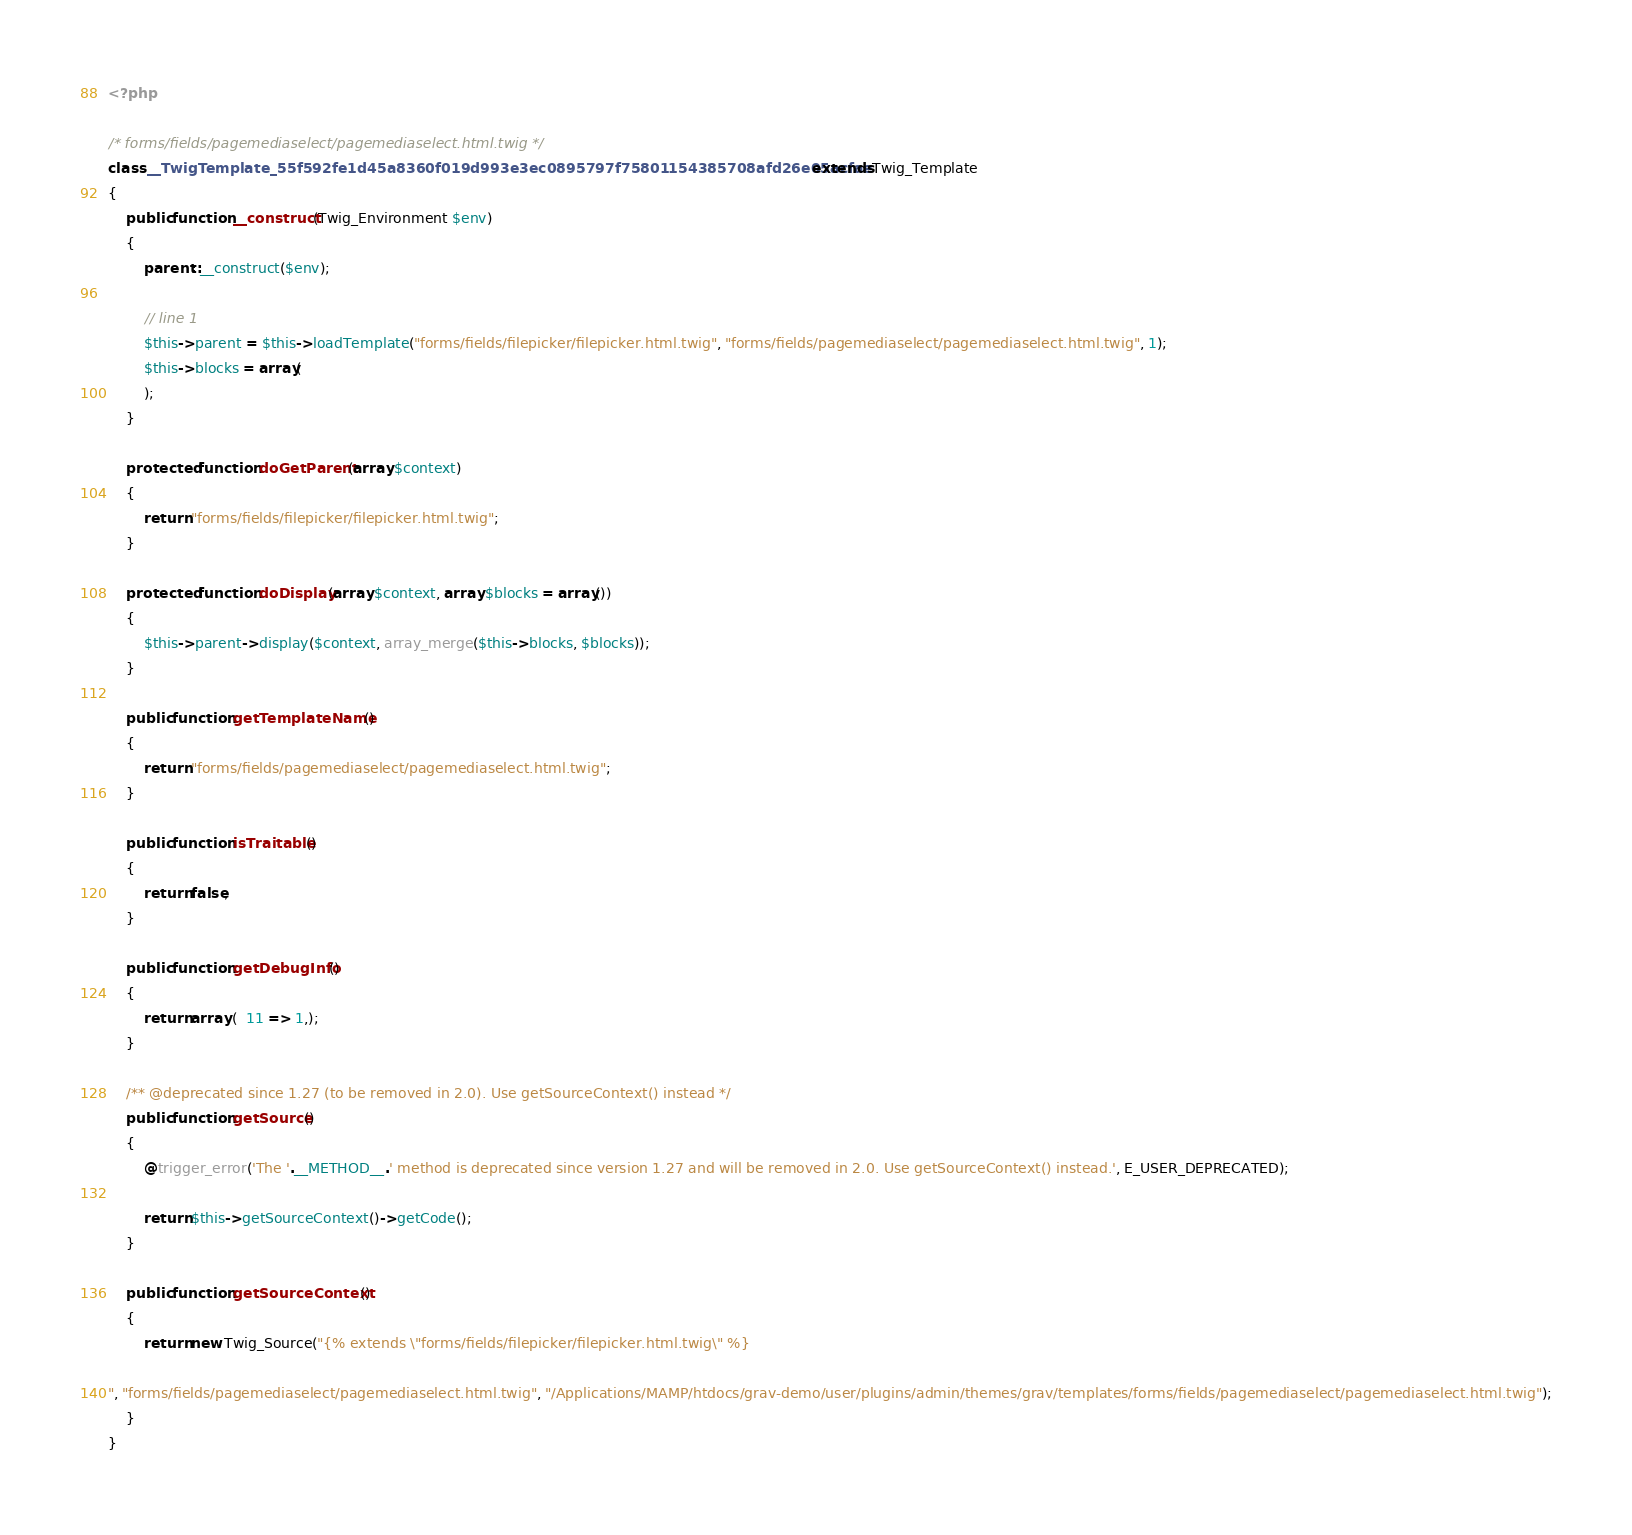Convert code to text. <code><loc_0><loc_0><loc_500><loc_500><_PHP_><?php

/* forms/fields/pagemediaselect/pagemediaselect.html.twig */
class __TwigTemplate_55f592fe1d45a8360f019d993e3ec0895797f75801154385708afd26e05acfae extends Twig_Template
{
    public function __construct(Twig_Environment $env)
    {
        parent::__construct($env);

        // line 1
        $this->parent = $this->loadTemplate("forms/fields/filepicker/filepicker.html.twig", "forms/fields/pagemediaselect/pagemediaselect.html.twig", 1);
        $this->blocks = array(
        );
    }

    protected function doGetParent(array $context)
    {
        return "forms/fields/filepicker/filepicker.html.twig";
    }

    protected function doDisplay(array $context, array $blocks = array())
    {
        $this->parent->display($context, array_merge($this->blocks, $blocks));
    }

    public function getTemplateName()
    {
        return "forms/fields/pagemediaselect/pagemediaselect.html.twig";
    }

    public function isTraitable()
    {
        return false;
    }

    public function getDebugInfo()
    {
        return array (  11 => 1,);
    }

    /** @deprecated since 1.27 (to be removed in 2.0). Use getSourceContext() instead */
    public function getSource()
    {
        @trigger_error('The '.__METHOD__.' method is deprecated since version 1.27 and will be removed in 2.0. Use getSourceContext() instead.', E_USER_DEPRECATED);

        return $this->getSourceContext()->getCode();
    }

    public function getSourceContext()
    {
        return new Twig_Source("{% extends \"forms/fields/filepicker/filepicker.html.twig\" %}

", "forms/fields/pagemediaselect/pagemediaselect.html.twig", "/Applications/MAMP/htdocs/grav-demo/user/plugins/admin/themes/grav/templates/forms/fields/pagemediaselect/pagemediaselect.html.twig");
    }
}
</code> 